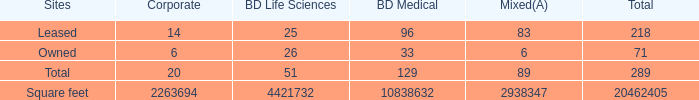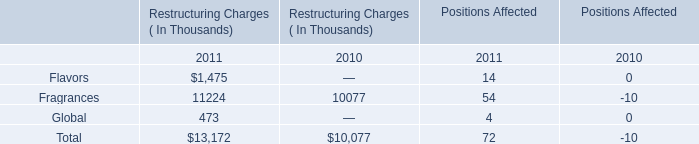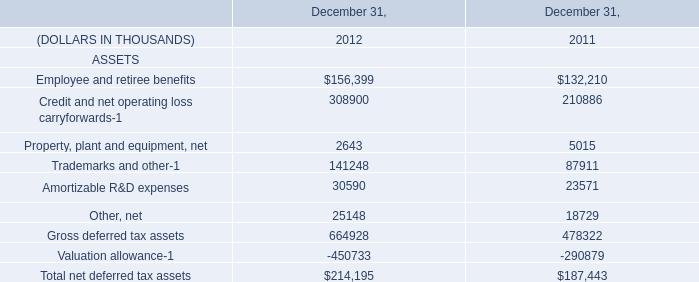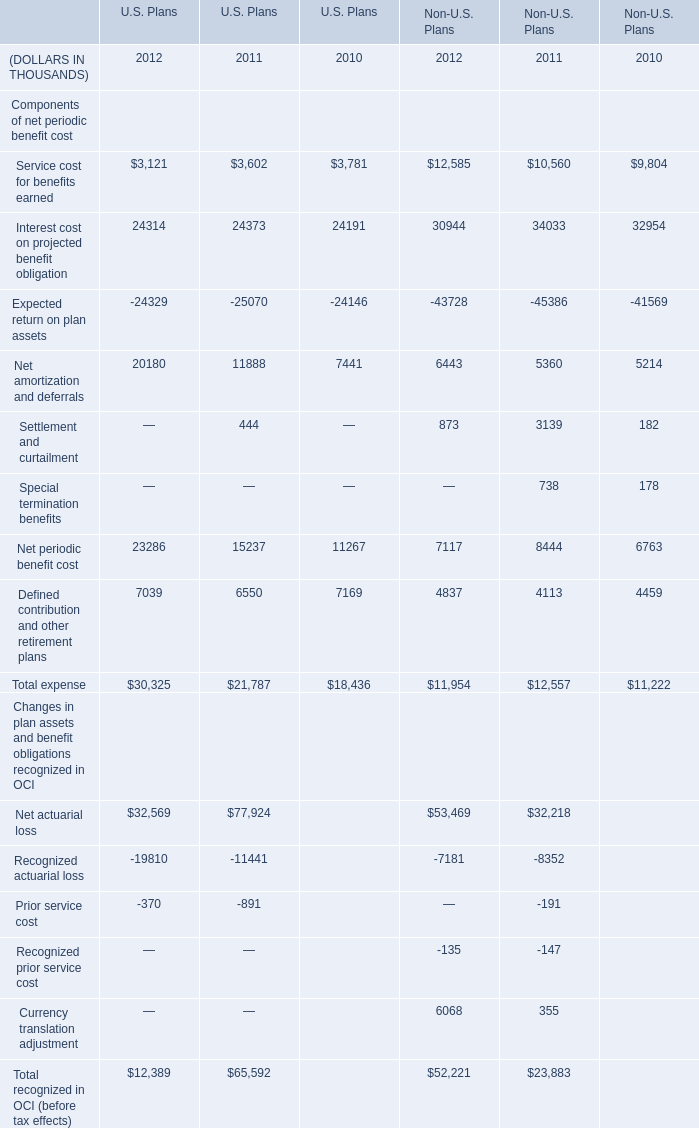What is the growing rate of Fragrances in Table 1 in the years with the least Defined contribution and other retirement plans of U.S. Plans in Table 3? 
Computations: ((11224 - 10077) / 10077)
Answer: 0.11382. 